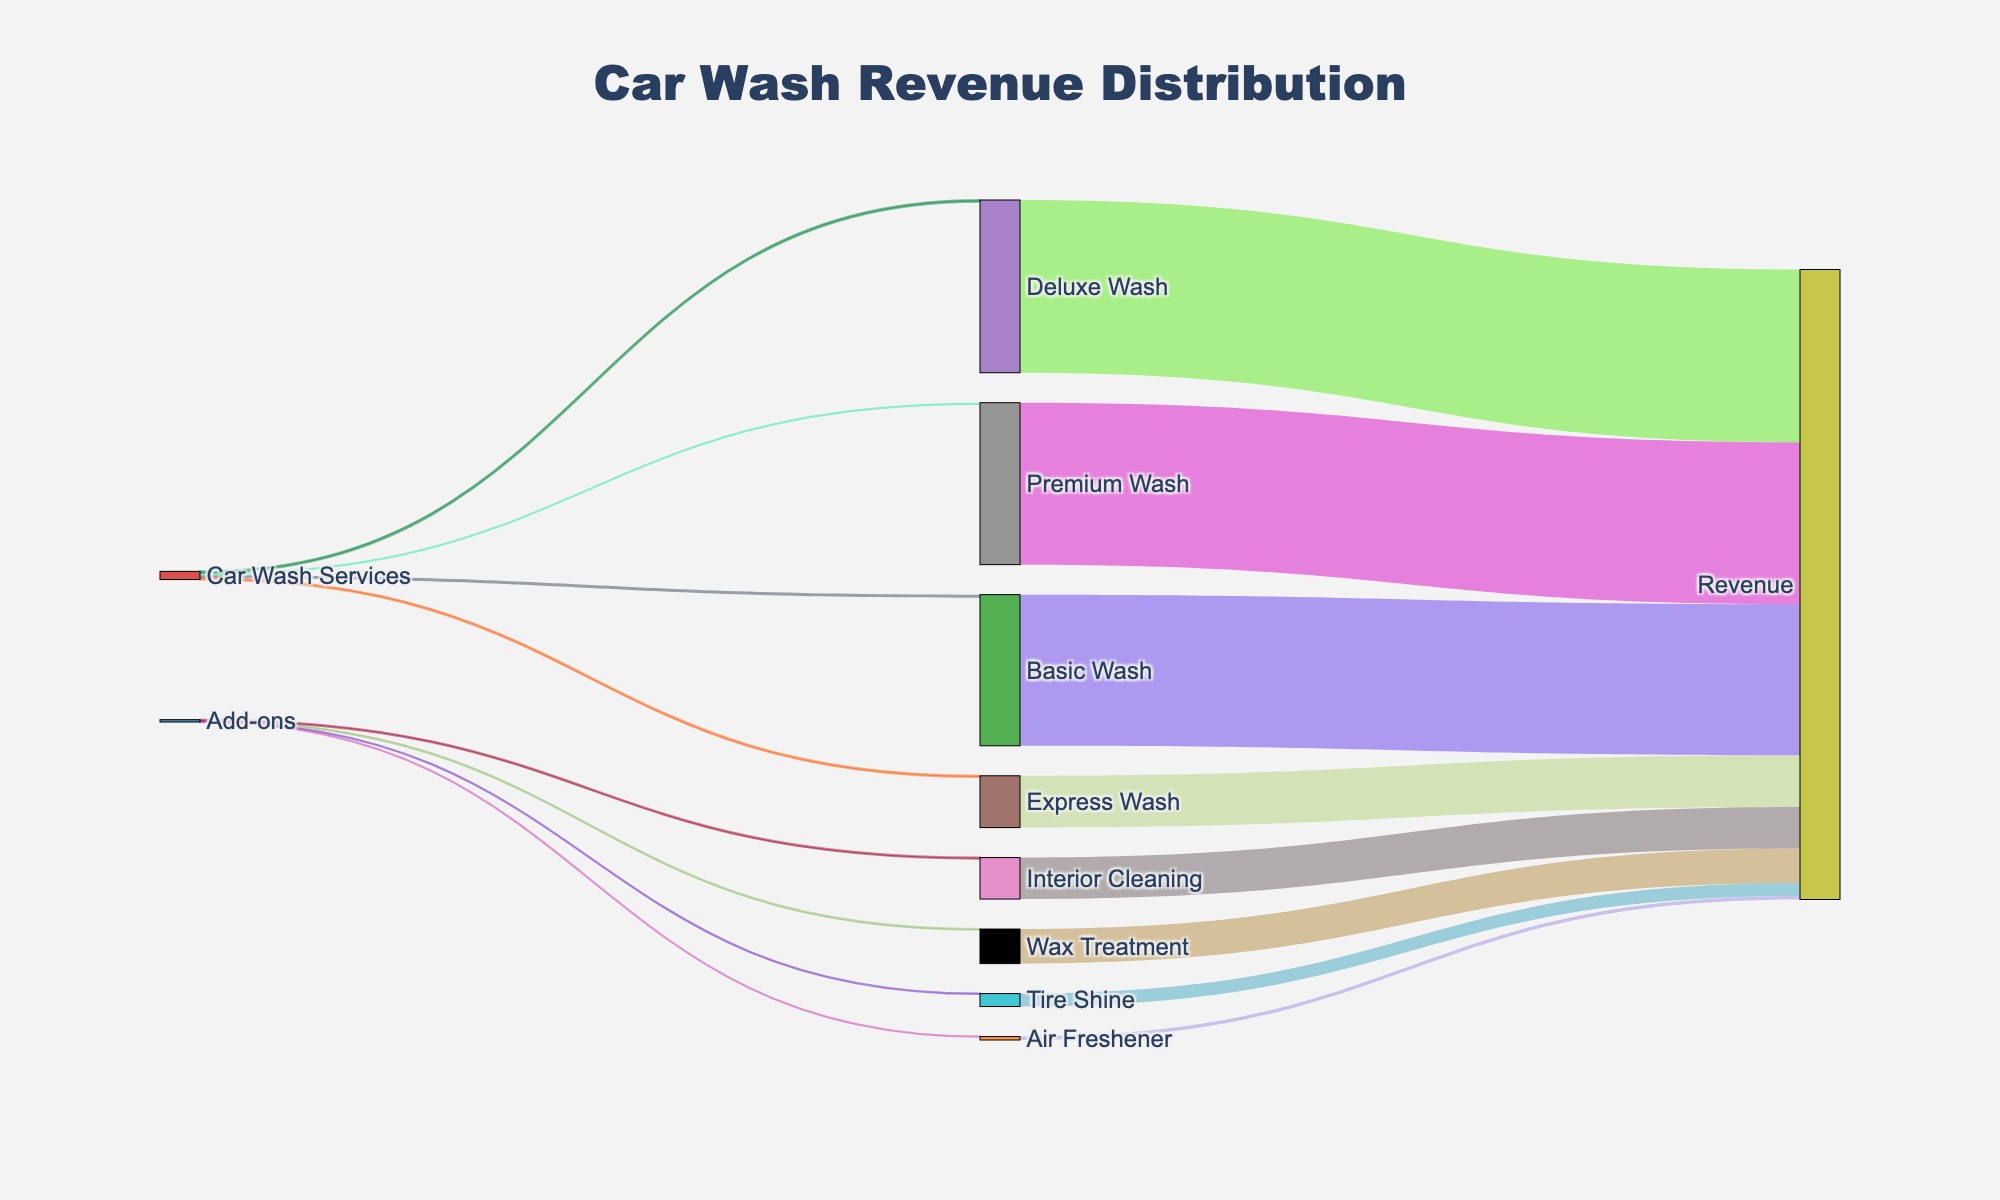How many types of car wash services are displayed in the diagram? There are four types of car wash services listed under "Car Wash Services" in the figure. They are Basic Wash, Premium Wash, Deluxe Wash, and Express Wash.
Answer: Four Which car wash service generates the highest revenue? From the diagram, Premium Wash generates the most revenue flowing into "Revenue" from "Premium Wash," with a value of $1875.
Answer: Premium Wash What is the difference in revenue between Deluxe Wash and Express Wash? Deluxe Wash contributes $2000 to Revenue, while Express Wash contributes $600. The difference is $2000 - $600 = $1400.
Answer: $1400 Which add-on generates the least revenue? The add-on with the smallest contribution to "Revenue" in the diagram is "Air Freshener," which generates $40.
Answer: Air Freshener How do the total revenues from car wash services and add-ons compare? Sum the revenues from all car wash services and compare to the sum of revenues from all add-ons. Car Wash Services total: $1750 + $1875 + $2000 + $600 = $6225. Add-ons total: $400 + $480 + $150 + $40 = $1070. Car wash services generate significantly more revenue.
Answer: Car Wash Services What is the combined revenue from both Tire Shine and Air Freshener? Tire Shine contributes $150 and Air Freshener contributes $40 to Revenue. The combined revenue is $150 + $40 = $190.
Answer: $190 Is the revenue generated from Basic Wash higher than that from Deluxe Wash? Basic Wash generates $1750 in revenue while Deluxe Wash generates $2000. Therefore, Basic Wash's revenue is not higher.
Answer: No What percentage of the Premium Wash revenue is of the total Car Wash Services revenue? Premium Wash revenue is $1875. Total car wash services revenue is $6225. The percentage is calculated as ($1875 / $6225) * 100 ≈ 30.1%.
Answer: 30.1% Which generates more revenue: Wax Treatment or Interior Cleaning? Wax Treatment generates $400 while Interior Cleaning generates $480. Interior Cleaning generates more revenue.
Answer: Interior Cleaning What proportion of the total revenue from car wash services does Express Wash contribute? Revenue from Express Wash is $600. Total car wash services revenue is $6225. The proportion is $600 / $6225 ≈ 0.0964 or 9.64%.
Answer: 9.64% 